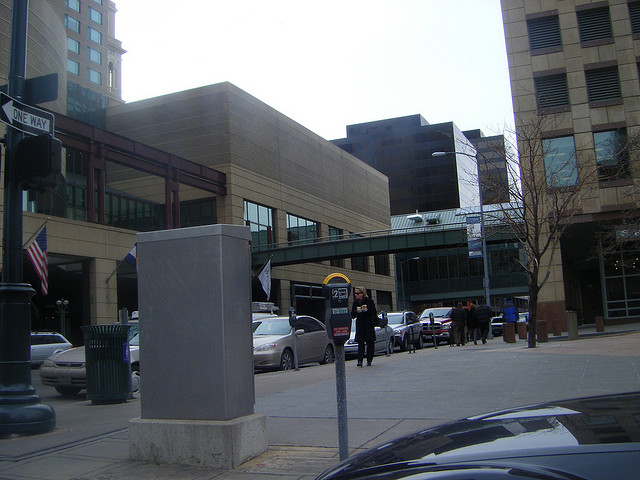Please identify all text content in this image. ONE WAY 